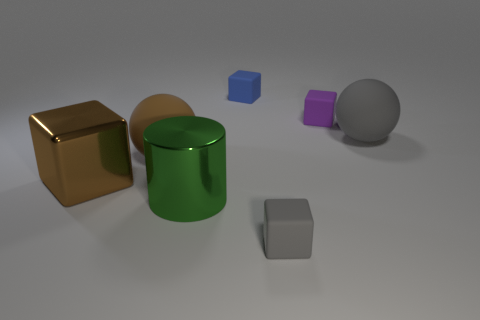Subtract all brown shiny blocks. How many blocks are left? 3 Add 2 large metal objects. How many objects exist? 9 Subtract all blocks. How many objects are left? 3 Subtract all blue cubes. How many cubes are left? 3 Subtract all small blue rubber things. Subtract all large blocks. How many objects are left? 5 Add 1 gray matte objects. How many gray matte objects are left? 3 Add 6 blue things. How many blue things exist? 7 Subtract 0 blue cylinders. How many objects are left? 7 Subtract 1 balls. How many balls are left? 1 Subtract all cyan cubes. Subtract all purple balls. How many cubes are left? 4 